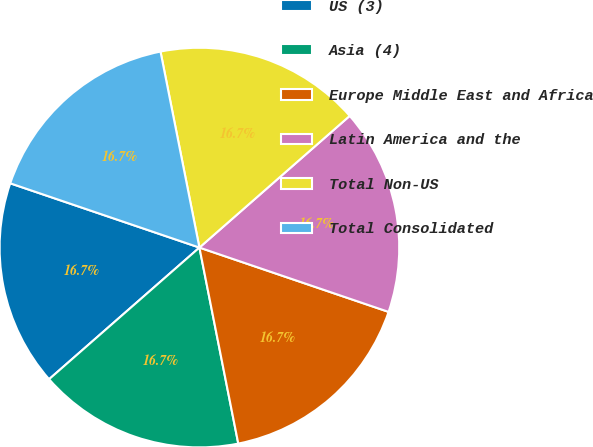Convert chart. <chart><loc_0><loc_0><loc_500><loc_500><pie_chart><fcel>US (3)<fcel>Asia (4)<fcel>Europe Middle East and Africa<fcel>Latin America and the<fcel>Total Non-US<fcel>Total Consolidated<nl><fcel>16.66%<fcel>16.67%<fcel>16.67%<fcel>16.67%<fcel>16.67%<fcel>16.67%<nl></chart> 